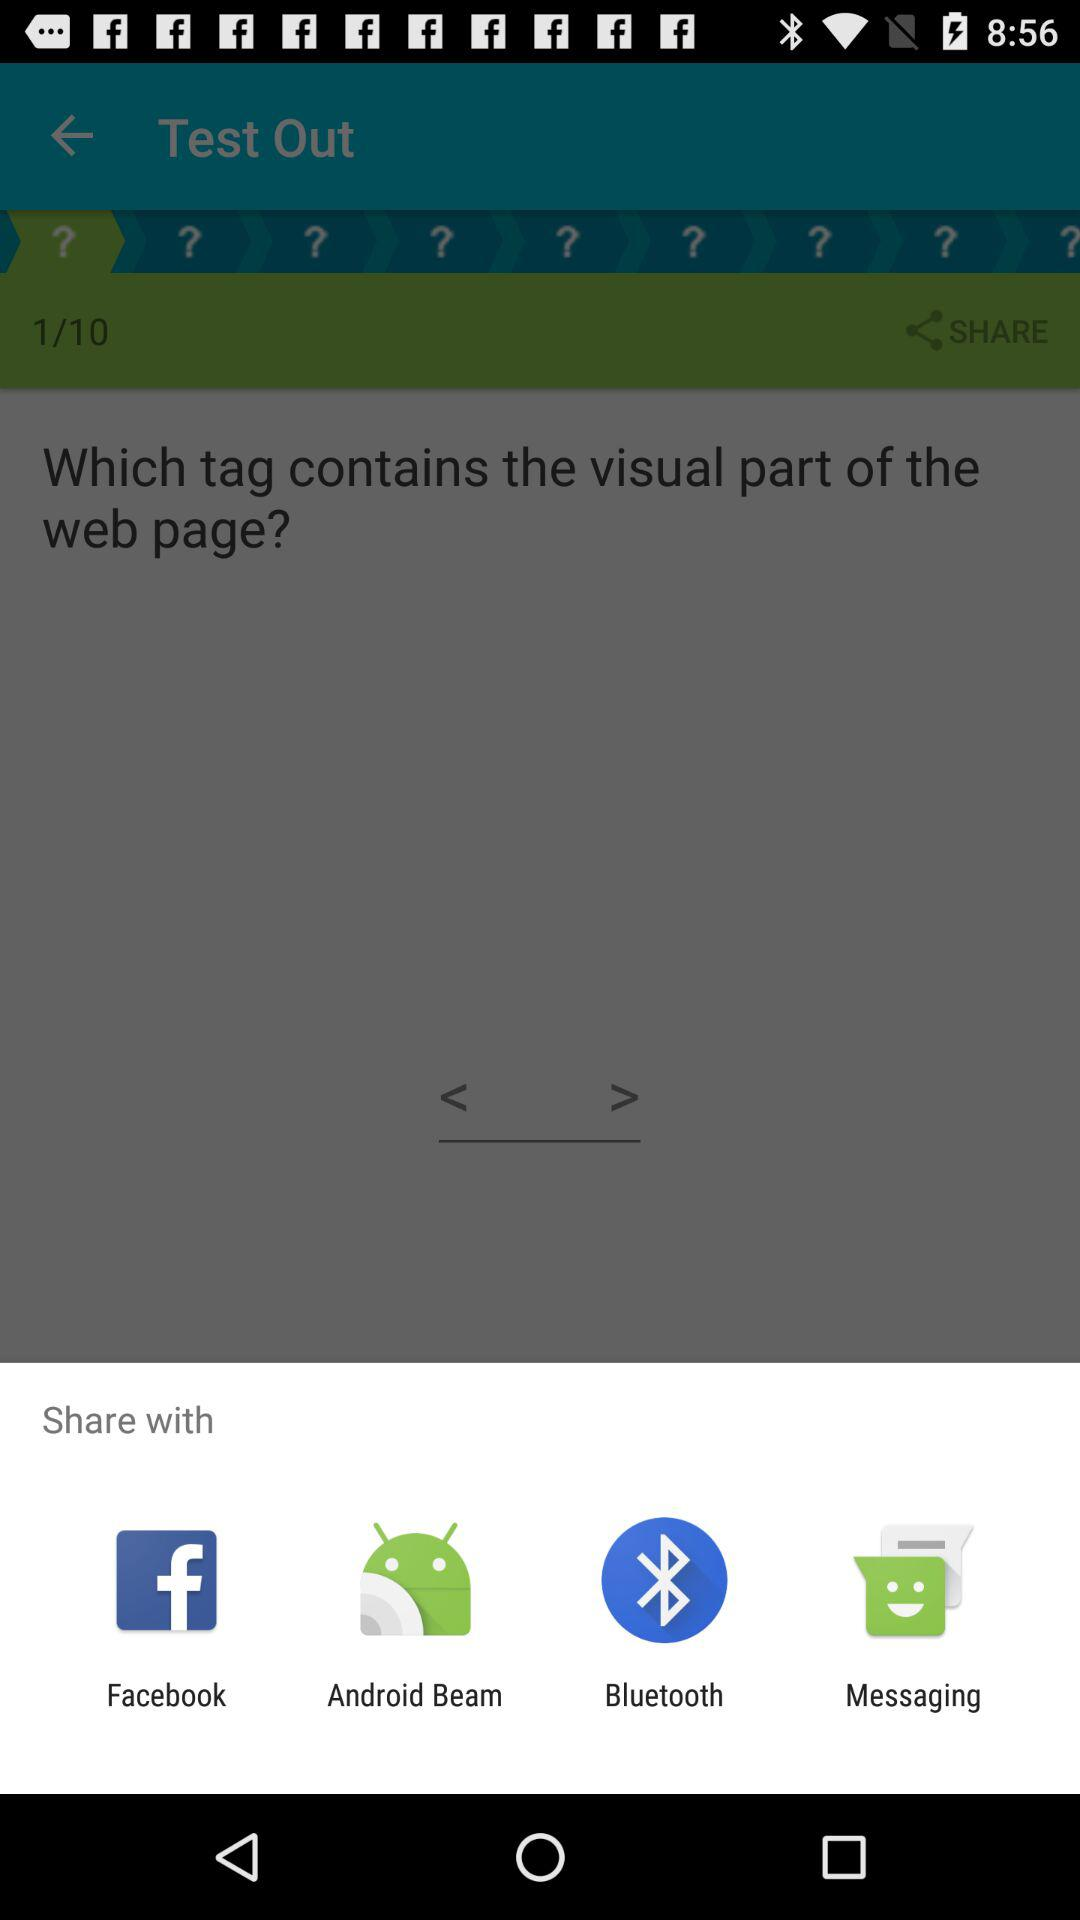How long does the user have to answer a question?
When the provided information is insufficient, respond with <no answer>. <no answer> 